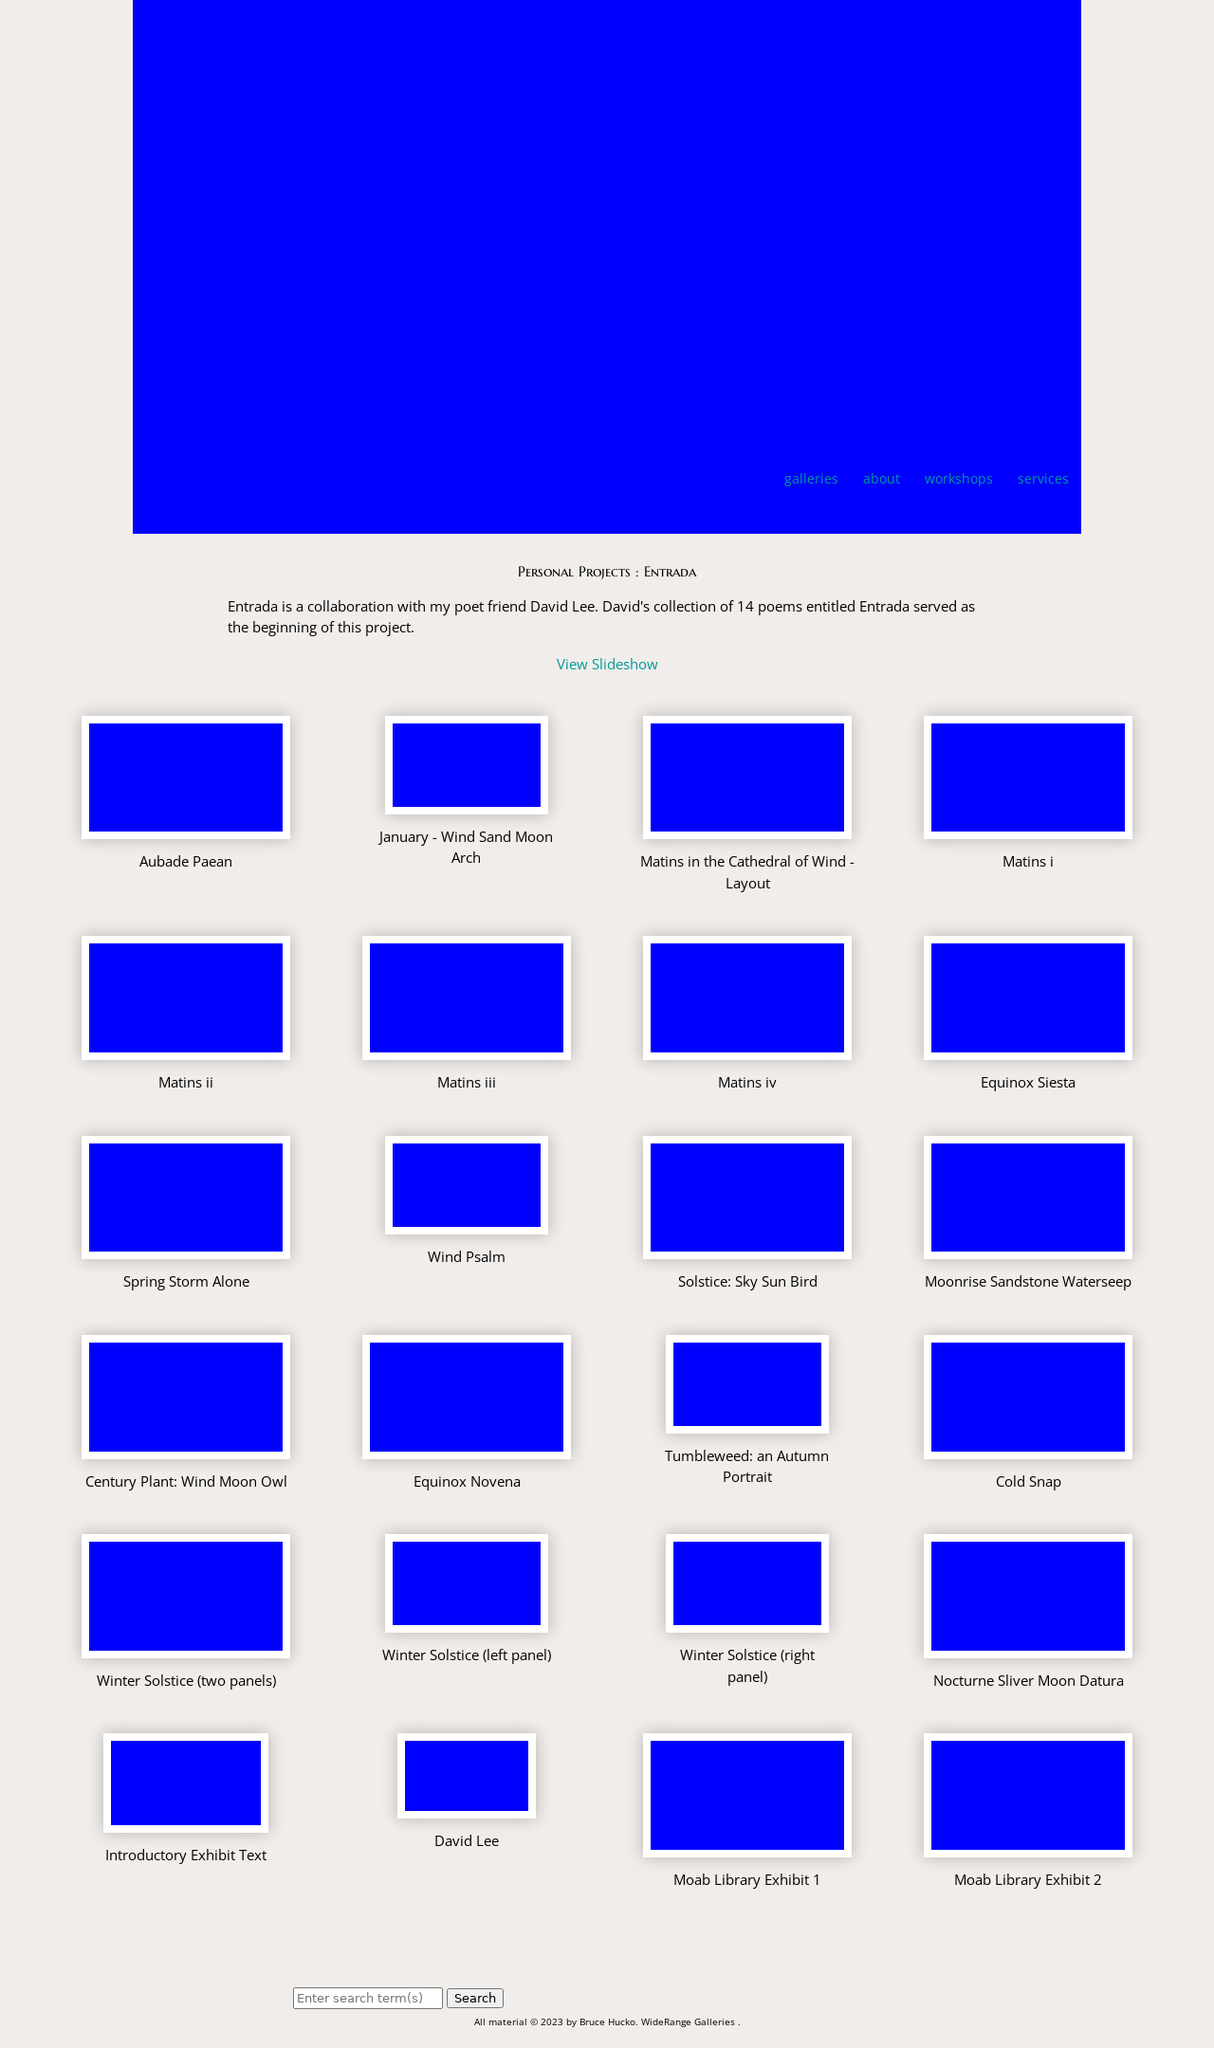What artistic themes are explored in the 'Entrada' project showcased on this website? The 'Entrada' project explores themes of natural landscapes and the unique interplay between visual art and poetry. It captures the essence of the natural world, particularly focusing on desert landscapes and their spiritual and aesthetic impact through the blend of photography by Bruce Hucko and poetry by David Lee.  Can you tell more about the collaboration between the photographer and poet for this project? Bruce Hucko and David Lee have collaboratively worked to fuse visual imagery with lyrical poetry, enhancing the emotive and narrative strength of each medium. This partnership aimed to create a multifaceted artistic expression that invites viewers and readers into deeper contemplation of the subjects portrayed. 